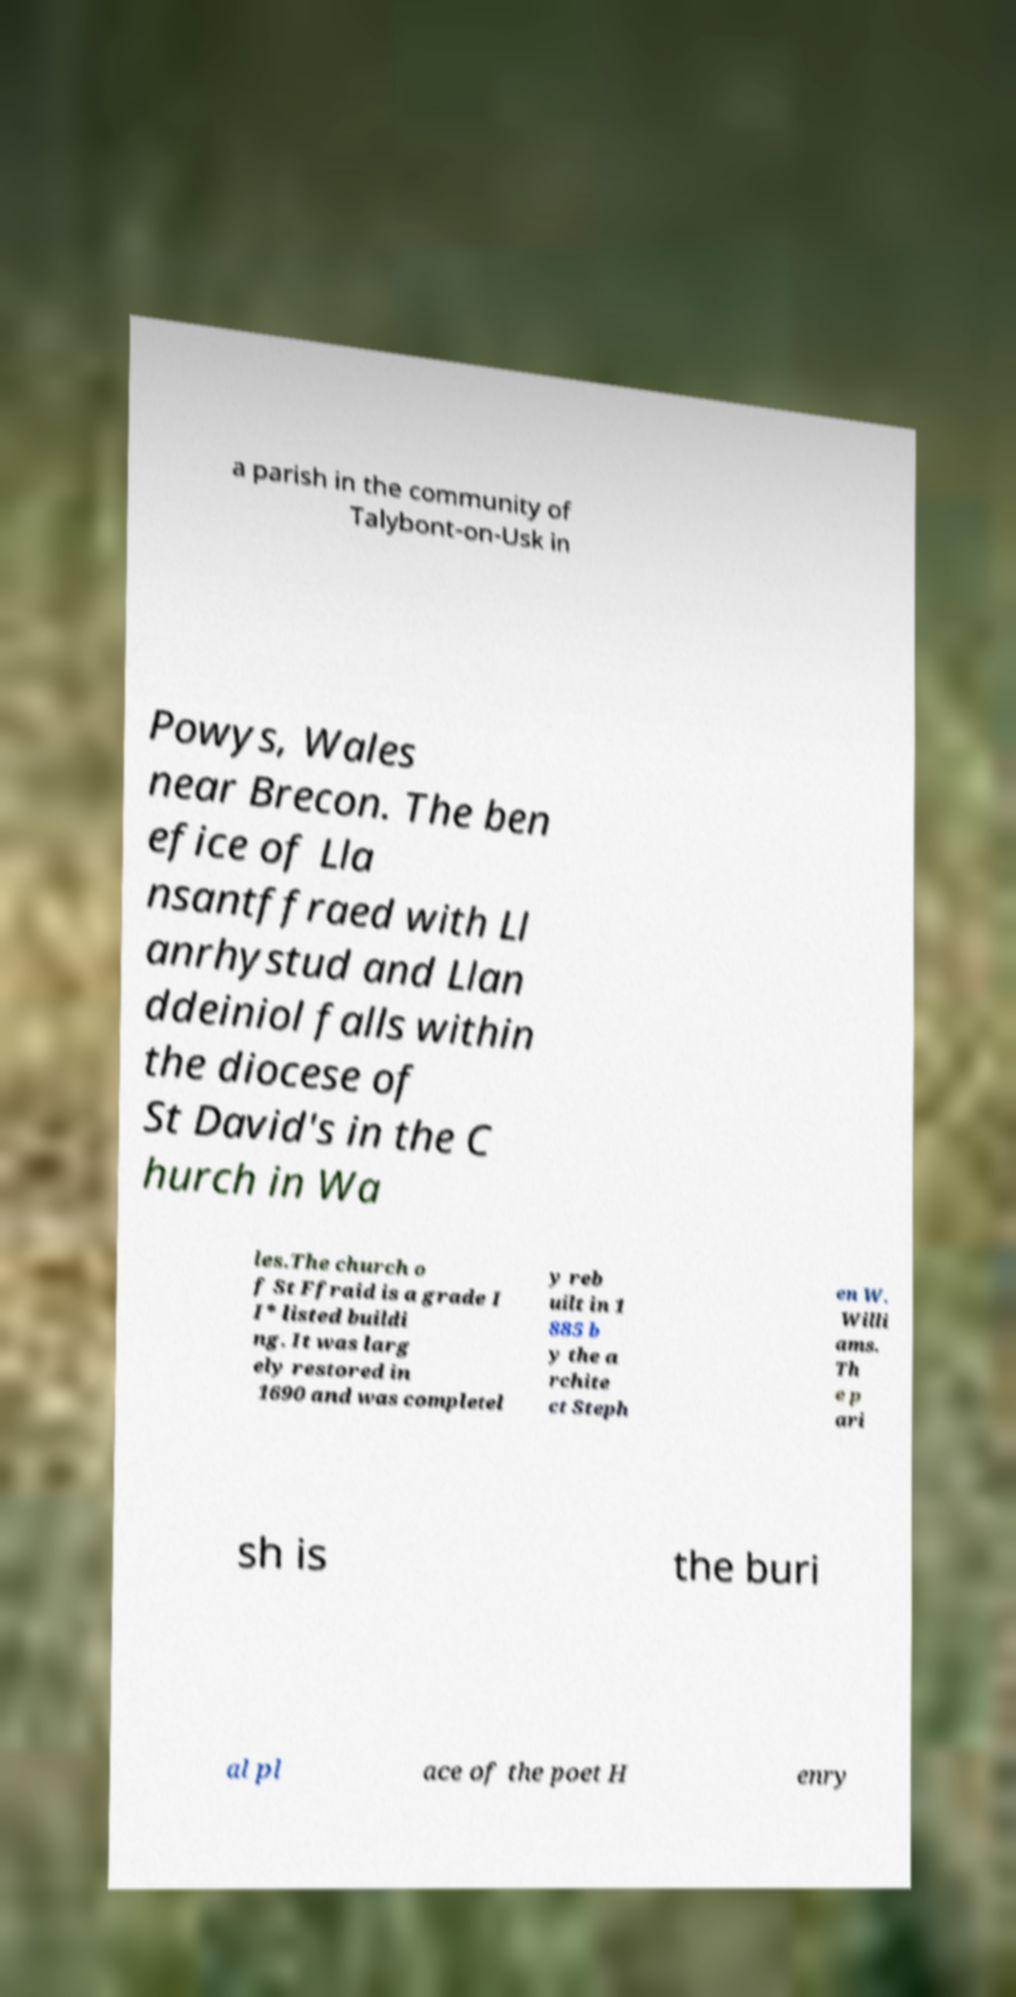There's text embedded in this image that I need extracted. Can you transcribe it verbatim? a parish in the community of Talybont-on-Usk in Powys, Wales near Brecon. The ben efice of Lla nsantffraed with Ll anrhystud and Llan ddeiniol falls within the diocese of St David's in the C hurch in Wa les.The church o f St Ffraid is a grade I I* listed buildi ng. It was larg ely restored in 1690 and was completel y reb uilt in 1 885 b y the a rchite ct Steph en W. Willi ams. Th e p ari sh is the buri al pl ace of the poet H enry 